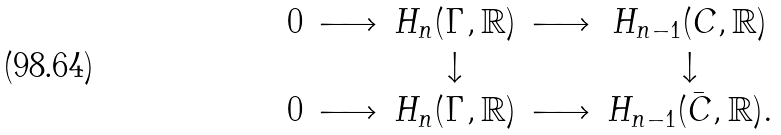Convert formula to latex. <formula><loc_0><loc_0><loc_500><loc_500>\begin{matrix} & 0 & \longrightarrow & H _ { n } ( \Gamma , \mathbb { R } ) & \longrightarrow & H _ { n - 1 } ( C , \mathbb { R } ) \\ & & & \downarrow & & \downarrow \\ & 0 & \longrightarrow & H _ { n } ( \Gamma , \mathbb { R } ) & \longrightarrow & H _ { n - 1 } ( \bar { C } , \mathbb { R } ) . \\ \end{matrix}</formula> 